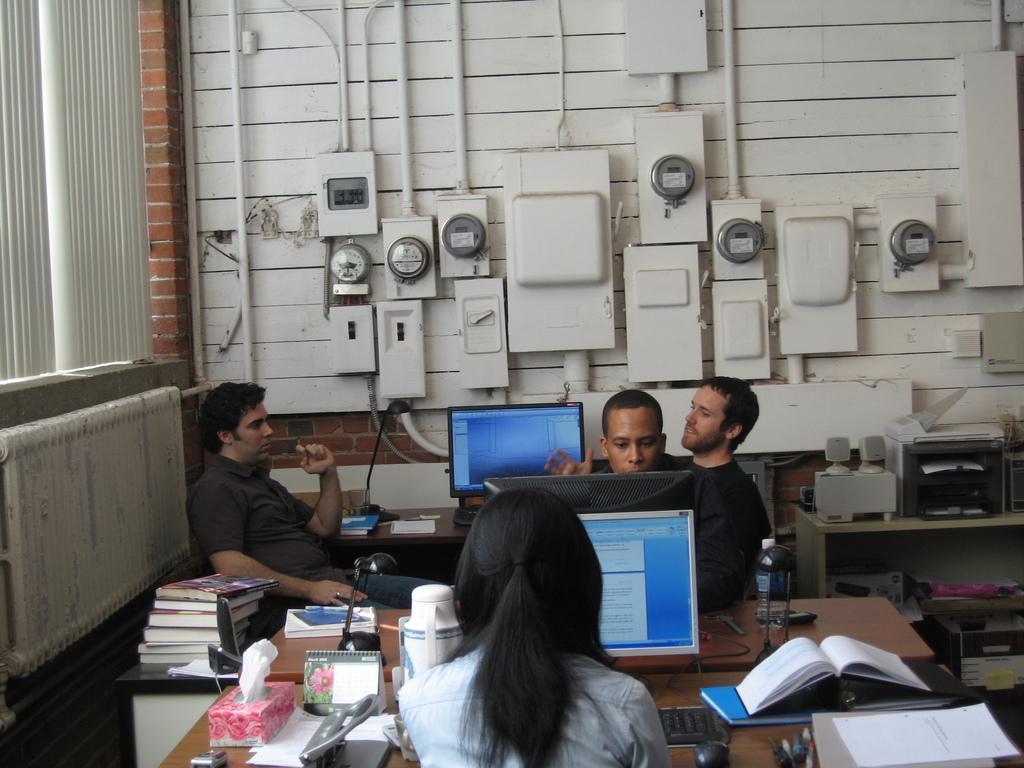In one or two sentences, can you explain what this image depicts? In this image i can see a group of people are sitting in front of a table. On the table I can see there is some monitor, few books and other objects on it. 